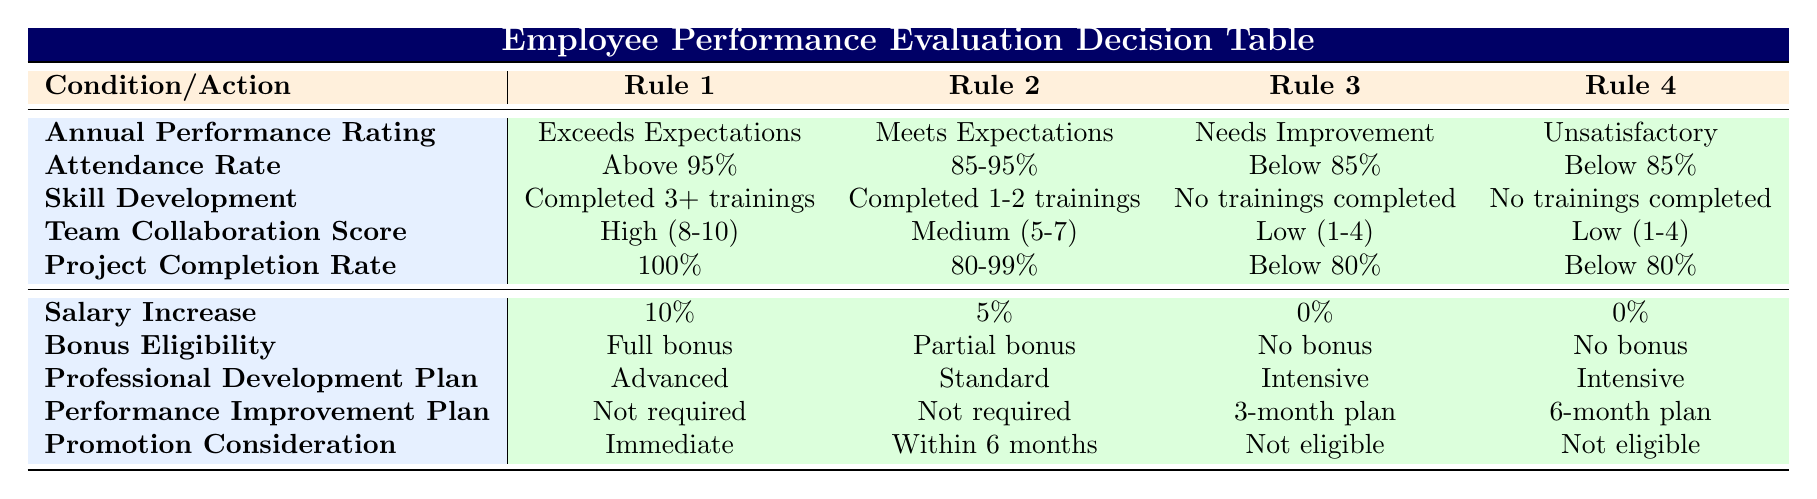What is the salary increase for an employee who exceeds expectations with above 95% attendance? According to Rule 1, when the annual performance rating is "Exceeds Expectations" and the attendance rate is "Above 95%", the salary increase is 10%.
Answer: 10% What bonus eligibility is assigned to an employee who meets expectations with an attendance rate between 85% to 95%? By looking at Rule 2, it shows that for an employee with "Meets Expectations" and attendance rate "85-95%", the bonus eligibility is "Partial bonus".
Answer: Partial bonus Is an employee who has a low team collaboration score and completed no trainings eligible for a salary increase? Referring to Rules 3 and 4, both employees with a "Low (1-4)" team collaboration score and "No trainings completed" receive a salary increase of 0%. Therefore, they are not eligible for a salary increase.
Answer: No What is the promotion consideration for an employee who has unsatisfactory performance but meets the training completion requirements? Rule 4 states that for "Unsatisfactory" performance, regardless of the number of trainings completed, the promotion consideration is "Not eligible".
Answer: Not eligible How many different salary increase percentages are listed in the decision table? The table shows four unique salary increase percentages: 10%, 5%, 2%, and 0%. Therefore, there are four different percentages.
Answer: Four What is the professional development plan for an employee with needs improvement in performance and attendance below 85%? According to both Rules 3 and 4, an employee with "Needs Improvement" performance and "Below 85%" attendance has an "Intensive" professional development plan.
Answer: Intensive If an employee has an attendance rate above 95% and completed 3 or more trainings but received a partial bonus, what does this imply about their performance rating? For the employee to have "Above 95%" attendance and "Completed 3+ trainings" according to Rule 1, they would need to have an "Exceeds Expectations" performance rating. Receiving a partial bonus contradicts this, suggesting an inconsistency.
Answer: Inconsistent data What is the average salary increase percentage across all rules? To find the average, we need to add the percentages (10 + 5 + 0 + 0) giving us 15, then divide by the number of rules (4): 15/4, which equals 3.75%.
Answer: 3.75% 